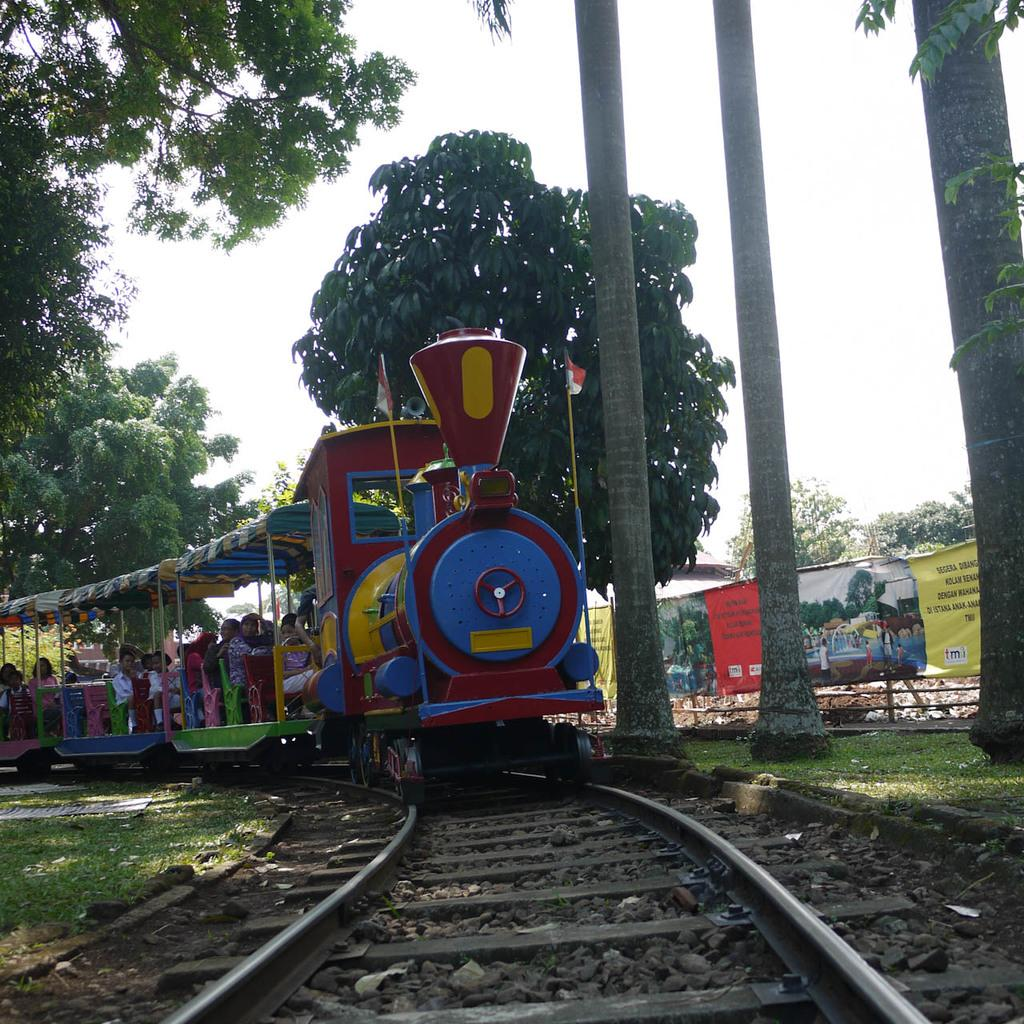What is the main subject of the image? The main subject of the image is a train. What are the people in the image doing? People are sitting in the train. What is the train doing in the image? The train is moving on a railway track. What type of vegetation can be seen in the image? There is grass visible in the image. What additional objects are present in the image? Banners are present in the image. What can be seen in the background of the image? Trees and the sky are visible in the background of the image. What type of prison can be seen in the image? There is no prison present in the image; it features a train moving on a railway track. What type of eggnog is being served to the passengers in the image? There is no eggnog present in the image; it features a train with people sitting inside. 